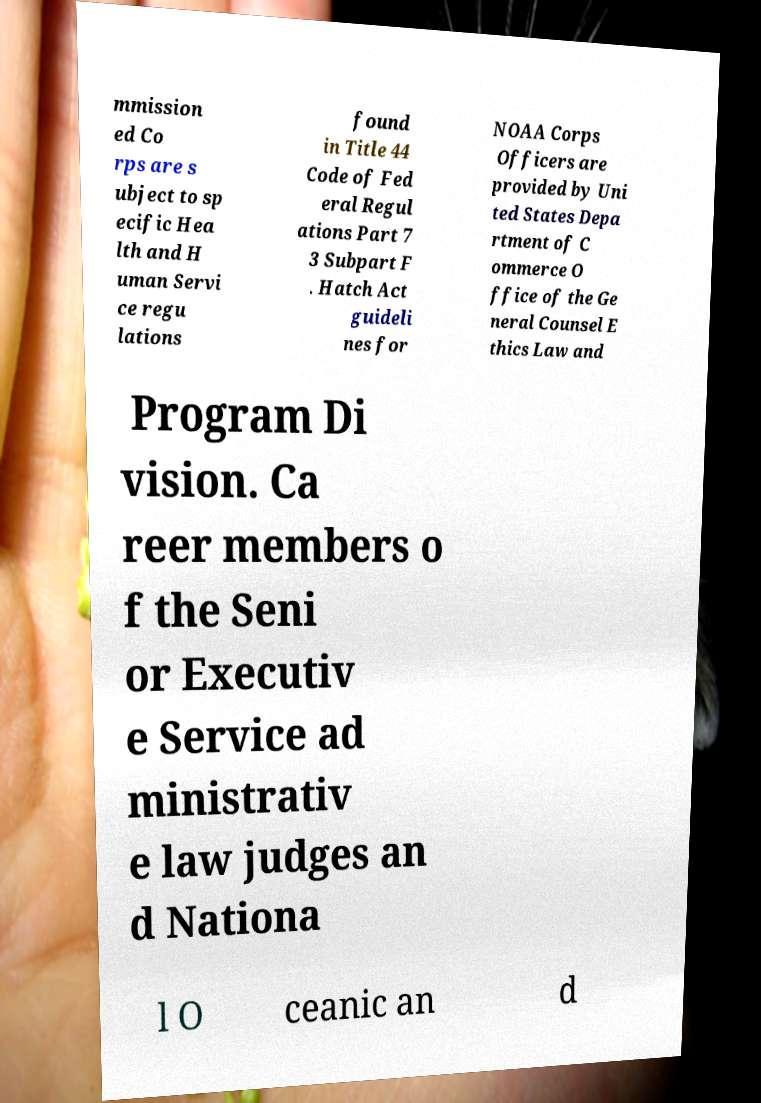I need the written content from this picture converted into text. Can you do that? mmission ed Co rps are s ubject to sp ecific Hea lth and H uman Servi ce regu lations found in Title 44 Code of Fed eral Regul ations Part 7 3 Subpart F . Hatch Act guideli nes for NOAA Corps Officers are provided by Uni ted States Depa rtment of C ommerce O ffice of the Ge neral Counsel E thics Law and Program Di vision. Ca reer members o f the Seni or Executiv e Service ad ministrativ e law judges an d Nationa l O ceanic an d 